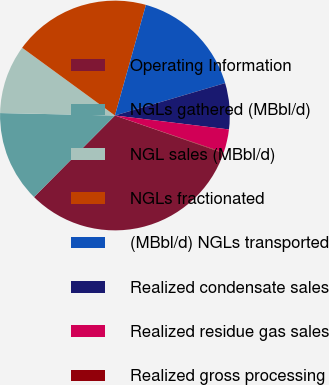Convert chart to OTSL. <chart><loc_0><loc_0><loc_500><loc_500><pie_chart><fcel>Operating Information<fcel>NGLs gathered (MBbl/d)<fcel>NGL sales (MBbl/d)<fcel>NGLs fractionated<fcel>(MBbl/d) NGLs transported<fcel>Realized condensate sales<fcel>Realized residue gas sales<fcel>Realized gross processing<nl><fcel>32.13%<fcel>12.9%<fcel>9.7%<fcel>19.31%<fcel>16.1%<fcel>6.49%<fcel>3.29%<fcel>0.08%<nl></chart> 